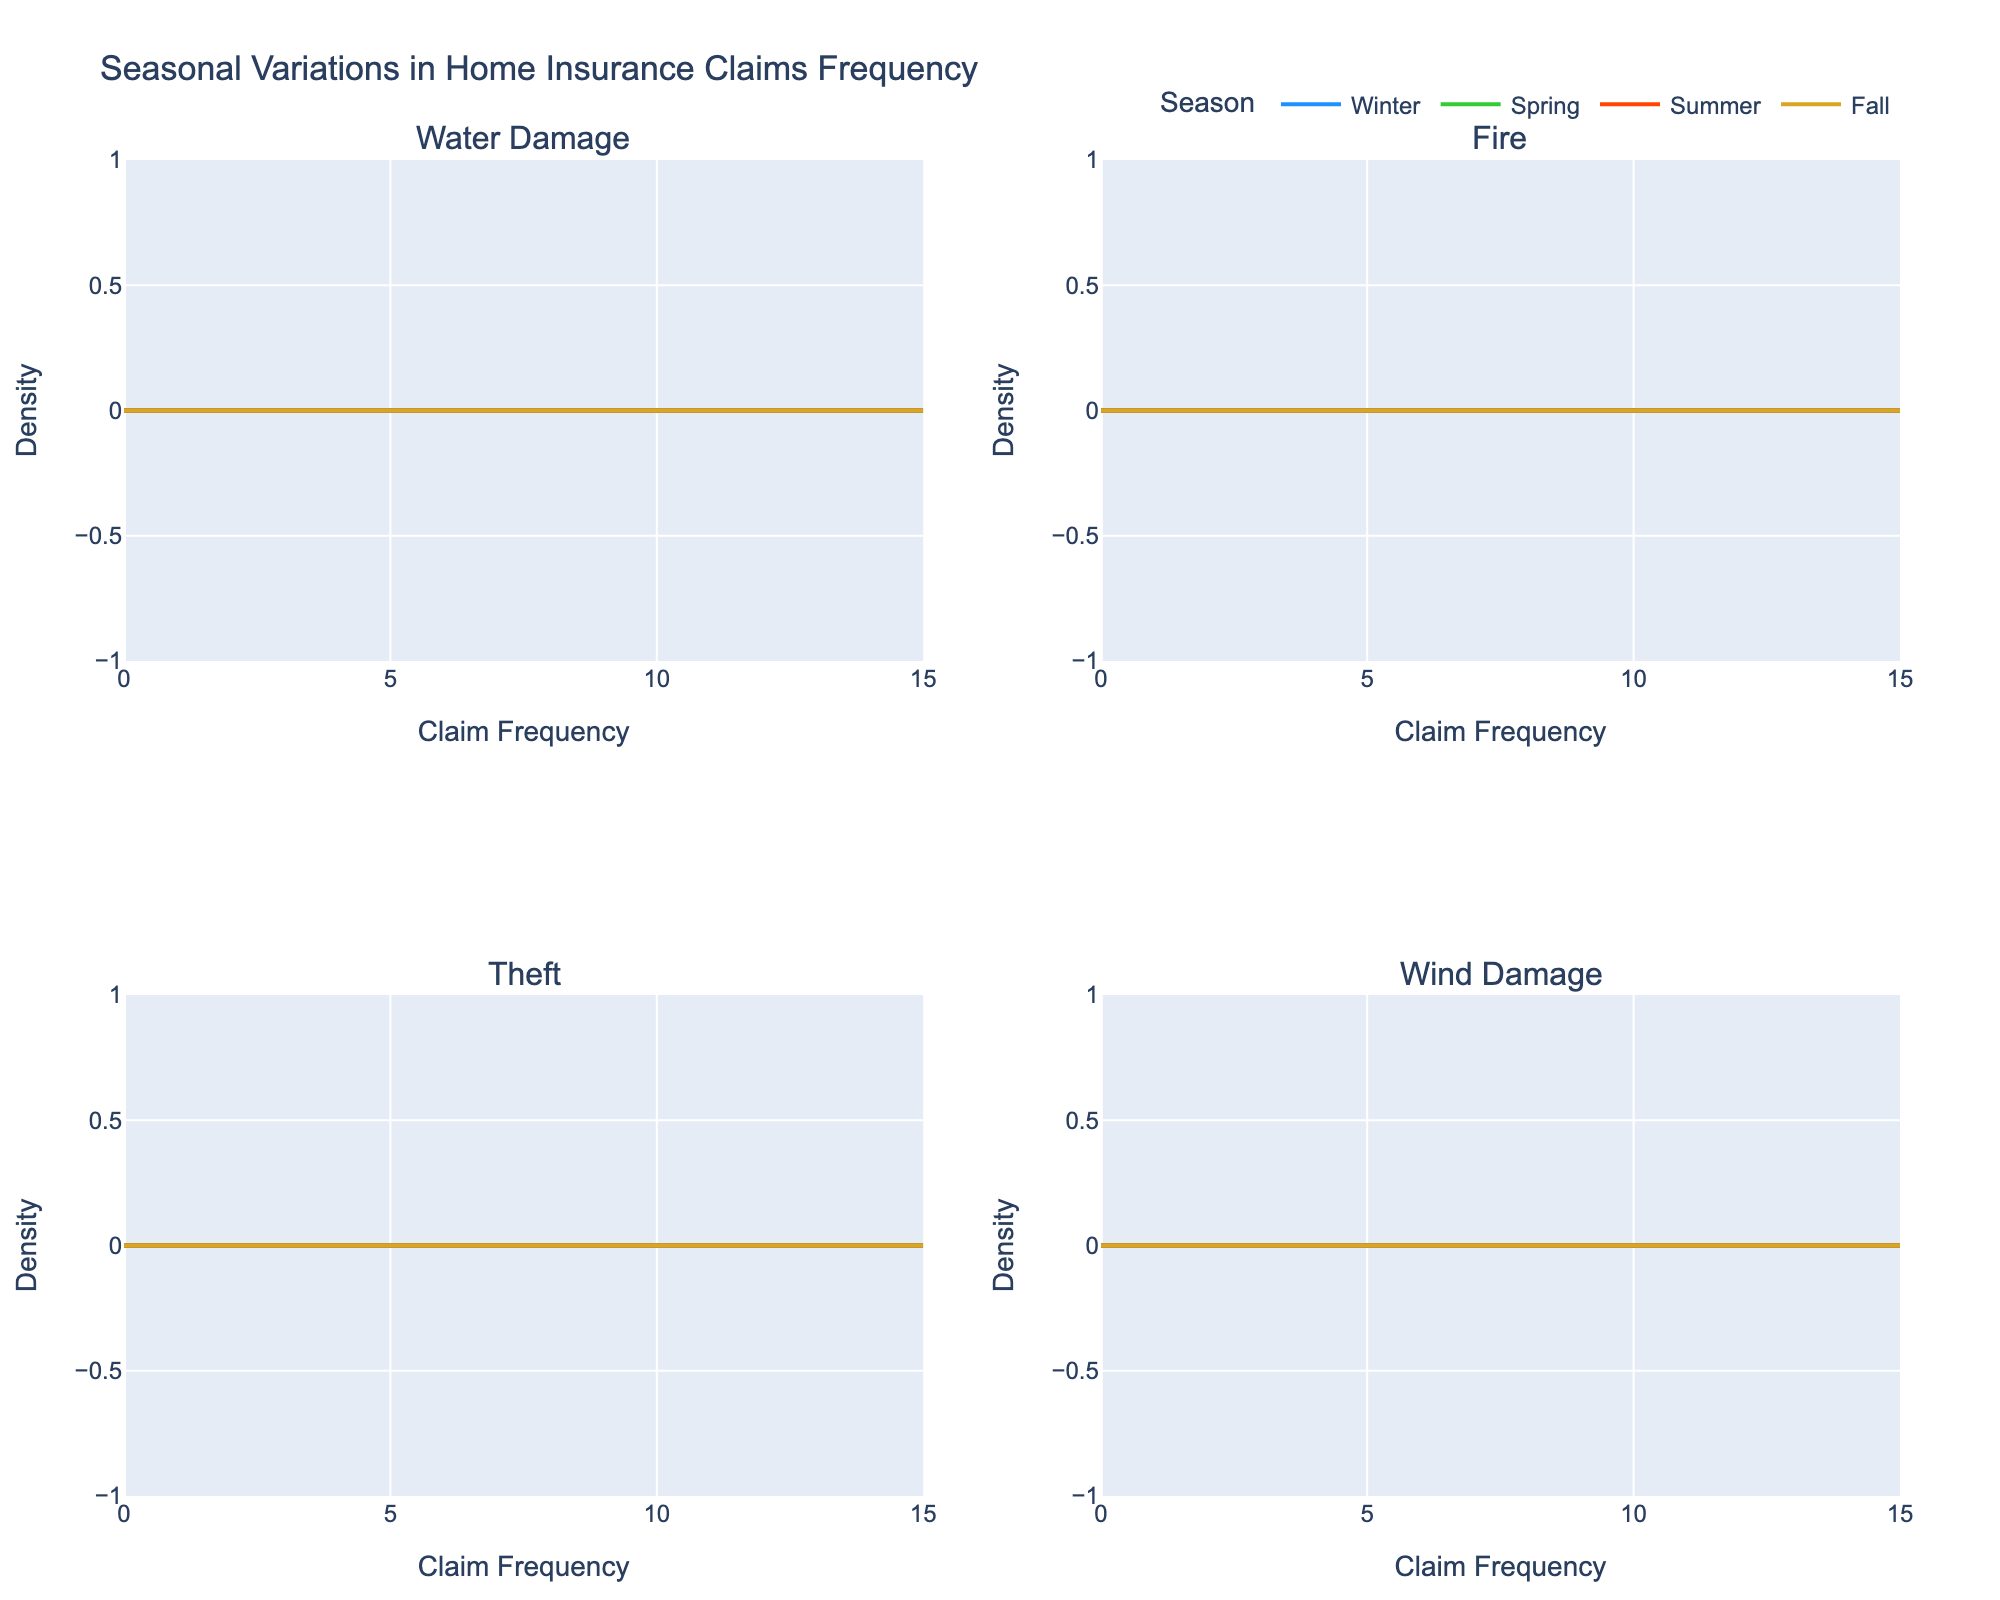What is the title of the figure? The title of the figure is displayed at the top of the plot. It reads "Seasonal Variations in Home Insurance Claims Frequency".
Answer: Seasonal Variations in Home Insurance Claims Frequency Which peril has the highest claim frequency in Winter? In the subplot titled "Water Damage", the density plot for Winter has the highest peak value for claim frequency around 12 as compared to the other subplots, suggesting Water Damage has the highest claim frequency in Winter.
Answer: Water Damage Which season has the lowest claim frequency for Fire? By examining the "Fire" subplot, the density curve for Spring shows the lowest claim frequency. The density at 5 for Spring is lower than for Summer, Winter, and Fall.
Answer: Spring Do Summer and Fall share similar density patterns for Theft? In the "Theft" subplot, the density curves for Summer and Fall are not identical, but they both peak around 9-10, suggesting a somewhat similar density pattern.
Answer: Yes What is the range of claim frequencies for Wind Damage across all seasons? To find the range, we check the lowest and highest claim frequencies in the "Wind Damage" subplot. The frequency ranges from around 7 (Summer) to 14 (Fall).
Answer: 7 to 14 Which season has the most spread-out claims for Water Damage? In the "Water Damage" subplot, the density plots show that the Spring season has more spread out claims, with significant density around 15 compared to other seasons.
Answer: Spring Which season has the second highest claim frequency for Theft? The subplot "Theft" shows that Summer has the highest claim frequency, followed by Fall with a frequency around 9. Thus, Fall has the second highest frequency.
Answer: Fall Comparing Fire and Theft claims in Summer, which peril has a higher maximum claim frequency? By comparing the "Fire" subplot and "Theft" subplot for Summer, Theft has a maximum frequency around 11, while Fire has around 9, thus Theft has a higher maximum claim frequency in Summer.
Answer: Theft Is the claim frequency for Wind Damage seasonally uniform? By observing the "Wind Damage" subplot, the density plots show significant differences among seasons: Winter and Spring have higher claim frequencies than Summer and Fall. So, it is not seasonally uniform.
Answer: No Out of all perils, which one has the lowest maximum claim frequency in any season? Evaluating all subplots and their peaks, the lowest maximum claim frequency (5) is observed for Fire in Spring.
Answer: Fire in Spring 